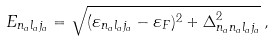<formula> <loc_0><loc_0><loc_500><loc_500>E _ { n _ { a } l _ { a } j _ { a } } = \sqrt { ( \varepsilon _ { n _ { a } l _ { a } j _ { a } } - \varepsilon _ { F } ) ^ { 2 } + \Delta _ { n _ { a } n _ { a } l _ { a } j _ { a } } ^ { 2 } } \, ,</formula> 